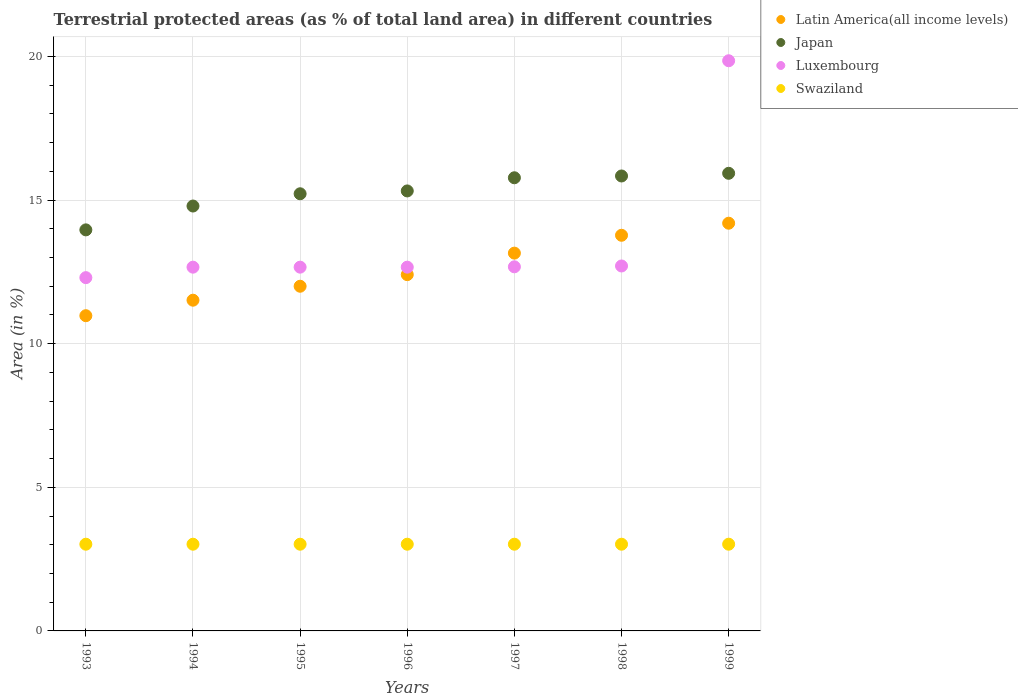How many different coloured dotlines are there?
Offer a very short reply. 4. What is the percentage of terrestrial protected land in Swaziland in 1996?
Your answer should be very brief. 3.02. Across all years, what is the maximum percentage of terrestrial protected land in Japan?
Provide a succinct answer. 15.93. Across all years, what is the minimum percentage of terrestrial protected land in Swaziland?
Make the answer very short. 3.02. In which year was the percentage of terrestrial protected land in Luxembourg maximum?
Offer a terse response. 1999. In which year was the percentage of terrestrial protected land in Japan minimum?
Keep it short and to the point. 1993. What is the total percentage of terrestrial protected land in Swaziland in the graph?
Offer a very short reply. 21.13. What is the difference between the percentage of terrestrial protected land in Latin America(all income levels) in 1998 and that in 1999?
Provide a short and direct response. -0.42. What is the difference between the percentage of terrestrial protected land in Luxembourg in 1998 and the percentage of terrestrial protected land in Swaziland in 1994?
Give a very brief answer. 9.69. What is the average percentage of terrestrial protected land in Swaziland per year?
Your response must be concise. 3.02. In the year 1999, what is the difference between the percentage of terrestrial protected land in Japan and percentage of terrestrial protected land in Latin America(all income levels)?
Your answer should be compact. 1.74. What is the ratio of the percentage of terrestrial protected land in Latin America(all income levels) in 1993 to that in 1999?
Offer a terse response. 0.77. What is the difference between the highest and the second highest percentage of terrestrial protected land in Luxembourg?
Ensure brevity in your answer.  7.14. What is the difference between the highest and the lowest percentage of terrestrial protected land in Japan?
Your answer should be compact. 1.97. Is it the case that in every year, the sum of the percentage of terrestrial protected land in Luxembourg and percentage of terrestrial protected land in Latin America(all income levels)  is greater than the percentage of terrestrial protected land in Swaziland?
Offer a terse response. Yes. Is the percentage of terrestrial protected land in Latin America(all income levels) strictly greater than the percentage of terrestrial protected land in Swaziland over the years?
Your answer should be very brief. Yes. What is the difference between two consecutive major ticks on the Y-axis?
Provide a short and direct response. 5. Are the values on the major ticks of Y-axis written in scientific E-notation?
Make the answer very short. No. Does the graph contain any zero values?
Keep it short and to the point. No. Where does the legend appear in the graph?
Provide a short and direct response. Top right. How many legend labels are there?
Offer a terse response. 4. What is the title of the graph?
Offer a terse response. Terrestrial protected areas (as % of total land area) in different countries. What is the label or title of the Y-axis?
Keep it short and to the point. Area (in %). What is the Area (in %) in Latin America(all income levels) in 1993?
Your response must be concise. 10.97. What is the Area (in %) in Japan in 1993?
Your answer should be compact. 13.96. What is the Area (in %) of Luxembourg in 1993?
Provide a short and direct response. 12.3. What is the Area (in %) in Swaziland in 1993?
Your answer should be very brief. 3.02. What is the Area (in %) of Latin America(all income levels) in 1994?
Keep it short and to the point. 11.51. What is the Area (in %) of Japan in 1994?
Offer a terse response. 14.79. What is the Area (in %) of Luxembourg in 1994?
Make the answer very short. 12.66. What is the Area (in %) of Swaziland in 1994?
Your response must be concise. 3.02. What is the Area (in %) of Latin America(all income levels) in 1995?
Ensure brevity in your answer.  12. What is the Area (in %) in Japan in 1995?
Offer a terse response. 15.22. What is the Area (in %) in Luxembourg in 1995?
Provide a short and direct response. 12.66. What is the Area (in %) in Swaziland in 1995?
Your answer should be compact. 3.02. What is the Area (in %) of Latin America(all income levels) in 1996?
Ensure brevity in your answer.  12.4. What is the Area (in %) in Japan in 1996?
Your response must be concise. 15.32. What is the Area (in %) in Luxembourg in 1996?
Keep it short and to the point. 12.66. What is the Area (in %) of Swaziland in 1996?
Your answer should be very brief. 3.02. What is the Area (in %) in Latin America(all income levels) in 1997?
Provide a succinct answer. 13.15. What is the Area (in %) in Japan in 1997?
Your answer should be very brief. 15.77. What is the Area (in %) in Luxembourg in 1997?
Your response must be concise. 12.67. What is the Area (in %) of Swaziland in 1997?
Your response must be concise. 3.02. What is the Area (in %) in Latin America(all income levels) in 1998?
Provide a succinct answer. 13.77. What is the Area (in %) in Japan in 1998?
Make the answer very short. 15.84. What is the Area (in %) of Luxembourg in 1998?
Keep it short and to the point. 12.7. What is the Area (in %) of Swaziland in 1998?
Keep it short and to the point. 3.02. What is the Area (in %) in Latin America(all income levels) in 1999?
Provide a succinct answer. 14.19. What is the Area (in %) of Japan in 1999?
Keep it short and to the point. 15.93. What is the Area (in %) in Luxembourg in 1999?
Give a very brief answer. 19.85. What is the Area (in %) in Swaziland in 1999?
Provide a short and direct response. 3.02. Across all years, what is the maximum Area (in %) in Latin America(all income levels)?
Provide a succinct answer. 14.19. Across all years, what is the maximum Area (in %) in Japan?
Your answer should be very brief. 15.93. Across all years, what is the maximum Area (in %) of Luxembourg?
Keep it short and to the point. 19.85. Across all years, what is the maximum Area (in %) of Swaziland?
Ensure brevity in your answer.  3.02. Across all years, what is the minimum Area (in %) in Latin America(all income levels)?
Make the answer very short. 10.97. Across all years, what is the minimum Area (in %) in Japan?
Provide a short and direct response. 13.96. Across all years, what is the minimum Area (in %) in Luxembourg?
Your answer should be very brief. 12.3. Across all years, what is the minimum Area (in %) of Swaziland?
Make the answer very short. 3.02. What is the total Area (in %) of Latin America(all income levels) in the graph?
Offer a terse response. 88. What is the total Area (in %) of Japan in the graph?
Provide a succinct answer. 106.83. What is the total Area (in %) in Luxembourg in the graph?
Your answer should be compact. 95.51. What is the total Area (in %) of Swaziland in the graph?
Your answer should be very brief. 21.13. What is the difference between the Area (in %) in Latin America(all income levels) in 1993 and that in 1994?
Your answer should be compact. -0.54. What is the difference between the Area (in %) in Japan in 1993 and that in 1994?
Ensure brevity in your answer.  -0.83. What is the difference between the Area (in %) in Luxembourg in 1993 and that in 1994?
Make the answer very short. -0.36. What is the difference between the Area (in %) in Swaziland in 1993 and that in 1994?
Give a very brief answer. 0. What is the difference between the Area (in %) in Latin America(all income levels) in 1993 and that in 1995?
Provide a succinct answer. -1.03. What is the difference between the Area (in %) of Japan in 1993 and that in 1995?
Your response must be concise. -1.26. What is the difference between the Area (in %) in Luxembourg in 1993 and that in 1995?
Give a very brief answer. -0.36. What is the difference between the Area (in %) of Swaziland in 1993 and that in 1995?
Make the answer very short. 0. What is the difference between the Area (in %) in Latin America(all income levels) in 1993 and that in 1996?
Your answer should be very brief. -1.43. What is the difference between the Area (in %) of Japan in 1993 and that in 1996?
Give a very brief answer. -1.36. What is the difference between the Area (in %) in Luxembourg in 1993 and that in 1996?
Give a very brief answer. -0.36. What is the difference between the Area (in %) in Latin America(all income levels) in 1993 and that in 1997?
Offer a terse response. -2.18. What is the difference between the Area (in %) in Japan in 1993 and that in 1997?
Your response must be concise. -1.81. What is the difference between the Area (in %) in Luxembourg in 1993 and that in 1997?
Make the answer very short. -0.38. What is the difference between the Area (in %) in Swaziland in 1993 and that in 1997?
Your answer should be compact. 0. What is the difference between the Area (in %) of Latin America(all income levels) in 1993 and that in 1998?
Ensure brevity in your answer.  -2.8. What is the difference between the Area (in %) of Japan in 1993 and that in 1998?
Your answer should be very brief. -1.88. What is the difference between the Area (in %) of Luxembourg in 1993 and that in 1998?
Make the answer very short. -0.41. What is the difference between the Area (in %) in Latin America(all income levels) in 1993 and that in 1999?
Provide a short and direct response. -3.22. What is the difference between the Area (in %) in Japan in 1993 and that in 1999?
Provide a short and direct response. -1.97. What is the difference between the Area (in %) in Luxembourg in 1993 and that in 1999?
Your answer should be very brief. -7.55. What is the difference between the Area (in %) of Swaziland in 1993 and that in 1999?
Give a very brief answer. 0. What is the difference between the Area (in %) of Latin America(all income levels) in 1994 and that in 1995?
Offer a terse response. -0.49. What is the difference between the Area (in %) in Japan in 1994 and that in 1995?
Make the answer very short. -0.43. What is the difference between the Area (in %) of Luxembourg in 1994 and that in 1995?
Your answer should be compact. 0. What is the difference between the Area (in %) of Latin America(all income levels) in 1994 and that in 1996?
Give a very brief answer. -0.89. What is the difference between the Area (in %) of Japan in 1994 and that in 1996?
Your answer should be very brief. -0.53. What is the difference between the Area (in %) in Swaziland in 1994 and that in 1996?
Provide a succinct answer. 0. What is the difference between the Area (in %) in Latin America(all income levels) in 1994 and that in 1997?
Provide a short and direct response. -1.64. What is the difference between the Area (in %) of Japan in 1994 and that in 1997?
Give a very brief answer. -0.98. What is the difference between the Area (in %) in Luxembourg in 1994 and that in 1997?
Your answer should be compact. -0.01. What is the difference between the Area (in %) in Swaziland in 1994 and that in 1997?
Your response must be concise. 0. What is the difference between the Area (in %) of Latin America(all income levels) in 1994 and that in 1998?
Offer a very short reply. -2.26. What is the difference between the Area (in %) of Japan in 1994 and that in 1998?
Provide a succinct answer. -1.05. What is the difference between the Area (in %) in Luxembourg in 1994 and that in 1998?
Give a very brief answer. -0.04. What is the difference between the Area (in %) of Latin America(all income levels) in 1994 and that in 1999?
Provide a short and direct response. -2.68. What is the difference between the Area (in %) of Japan in 1994 and that in 1999?
Give a very brief answer. -1.14. What is the difference between the Area (in %) of Luxembourg in 1994 and that in 1999?
Offer a very short reply. -7.19. What is the difference between the Area (in %) in Swaziland in 1994 and that in 1999?
Your answer should be very brief. 0. What is the difference between the Area (in %) in Latin America(all income levels) in 1995 and that in 1996?
Keep it short and to the point. -0.4. What is the difference between the Area (in %) in Japan in 1995 and that in 1996?
Your answer should be very brief. -0.1. What is the difference between the Area (in %) in Latin America(all income levels) in 1995 and that in 1997?
Your answer should be very brief. -1.15. What is the difference between the Area (in %) of Japan in 1995 and that in 1997?
Offer a very short reply. -0.56. What is the difference between the Area (in %) in Luxembourg in 1995 and that in 1997?
Offer a very short reply. -0.01. What is the difference between the Area (in %) in Swaziland in 1995 and that in 1997?
Keep it short and to the point. 0. What is the difference between the Area (in %) in Latin America(all income levels) in 1995 and that in 1998?
Offer a terse response. -1.77. What is the difference between the Area (in %) in Japan in 1995 and that in 1998?
Make the answer very short. -0.62. What is the difference between the Area (in %) of Luxembourg in 1995 and that in 1998?
Your answer should be very brief. -0.04. What is the difference between the Area (in %) of Latin America(all income levels) in 1995 and that in 1999?
Keep it short and to the point. -2.19. What is the difference between the Area (in %) of Japan in 1995 and that in 1999?
Your answer should be very brief. -0.71. What is the difference between the Area (in %) in Luxembourg in 1995 and that in 1999?
Provide a short and direct response. -7.19. What is the difference between the Area (in %) of Latin America(all income levels) in 1996 and that in 1997?
Your response must be concise. -0.75. What is the difference between the Area (in %) in Japan in 1996 and that in 1997?
Your answer should be compact. -0.46. What is the difference between the Area (in %) in Luxembourg in 1996 and that in 1997?
Ensure brevity in your answer.  -0.01. What is the difference between the Area (in %) of Latin America(all income levels) in 1996 and that in 1998?
Provide a succinct answer. -1.37. What is the difference between the Area (in %) of Japan in 1996 and that in 1998?
Keep it short and to the point. -0.52. What is the difference between the Area (in %) in Luxembourg in 1996 and that in 1998?
Provide a succinct answer. -0.04. What is the difference between the Area (in %) in Swaziland in 1996 and that in 1998?
Your response must be concise. 0. What is the difference between the Area (in %) of Latin America(all income levels) in 1996 and that in 1999?
Your answer should be compact. -1.79. What is the difference between the Area (in %) in Japan in 1996 and that in 1999?
Provide a short and direct response. -0.61. What is the difference between the Area (in %) of Luxembourg in 1996 and that in 1999?
Give a very brief answer. -7.19. What is the difference between the Area (in %) of Latin America(all income levels) in 1997 and that in 1998?
Ensure brevity in your answer.  -0.62. What is the difference between the Area (in %) of Japan in 1997 and that in 1998?
Offer a terse response. -0.06. What is the difference between the Area (in %) in Luxembourg in 1997 and that in 1998?
Your answer should be very brief. -0.03. What is the difference between the Area (in %) of Swaziland in 1997 and that in 1998?
Provide a succinct answer. 0. What is the difference between the Area (in %) in Latin America(all income levels) in 1997 and that in 1999?
Offer a very short reply. -1.04. What is the difference between the Area (in %) of Japan in 1997 and that in 1999?
Your response must be concise. -0.16. What is the difference between the Area (in %) in Luxembourg in 1997 and that in 1999?
Make the answer very short. -7.17. What is the difference between the Area (in %) in Latin America(all income levels) in 1998 and that in 1999?
Your answer should be very brief. -0.42. What is the difference between the Area (in %) of Japan in 1998 and that in 1999?
Keep it short and to the point. -0.09. What is the difference between the Area (in %) in Luxembourg in 1998 and that in 1999?
Offer a terse response. -7.14. What is the difference between the Area (in %) in Latin America(all income levels) in 1993 and the Area (in %) in Japan in 1994?
Your answer should be compact. -3.82. What is the difference between the Area (in %) of Latin America(all income levels) in 1993 and the Area (in %) of Luxembourg in 1994?
Provide a short and direct response. -1.69. What is the difference between the Area (in %) of Latin America(all income levels) in 1993 and the Area (in %) of Swaziland in 1994?
Keep it short and to the point. 7.95. What is the difference between the Area (in %) of Japan in 1993 and the Area (in %) of Luxembourg in 1994?
Your answer should be compact. 1.3. What is the difference between the Area (in %) of Japan in 1993 and the Area (in %) of Swaziland in 1994?
Keep it short and to the point. 10.94. What is the difference between the Area (in %) of Luxembourg in 1993 and the Area (in %) of Swaziland in 1994?
Your response must be concise. 9.28. What is the difference between the Area (in %) of Latin America(all income levels) in 1993 and the Area (in %) of Japan in 1995?
Your response must be concise. -4.24. What is the difference between the Area (in %) of Latin America(all income levels) in 1993 and the Area (in %) of Luxembourg in 1995?
Provide a succinct answer. -1.69. What is the difference between the Area (in %) of Latin America(all income levels) in 1993 and the Area (in %) of Swaziland in 1995?
Your answer should be very brief. 7.95. What is the difference between the Area (in %) of Japan in 1993 and the Area (in %) of Luxembourg in 1995?
Offer a very short reply. 1.3. What is the difference between the Area (in %) of Japan in 1993 and the Area (in %) of Swaziland in 1995?
Provide a succinct answer. 10.94. What is the difference between the Area (in %) of Luxembourg in 1993 and the Area (in %) of Swaziland in 1995?
Your response must be concise. 9.28. What is the difference between the Area (in %) in Latin America(all income levels) in 1993 and the Area (in %) in Japan in 1996?
Give a very brief answer. -4.34. What is the difference between the Area (in %) of Latin America(all income levels) in 1993 and the Area (in %) of Luxembourg in 1996?
Your response must be concise. -1.69. What is the difference between the Area (in %) in Latin America(all income levels) in 1993 and the Area (in %) in Swaziland in 1996?
Offer a very short reply. 7.95. What is the difference between the Area (in %) of Japan in 1993 and the Area (in %) of Luxembourg in 1996?
Make the answer very short. 1.3. What is the difference between the Area (in %) in Japan in 1993 and the Area (in %) in Swaziland in 1996?
Offer a terse response. 10.94. What is the difference between the Area (in %) in Luxembourg in 1993 and the Area (in %) in Swaziland in 1996?
Make the answer very short. 9.28. What is the difference between the Area (in %) in Latin America(all income levels) in 1993 and the Area (in %) in Japan in 1997?
Offer a terse response. -4.8. What is the difference between the Area (in %) of Latin America(all income levels) in 1993 and the Area (in %) of Luxembourg in 1997?
Your response must be concise. -1.7. What is the difference between the Area (in %) in Latin America(all income levels) in 1993 and the Area (in %) in Swaziland in 1997?
Keep it short and to the point. 7.95. What is the difference between the Area (in %) in Japan in 1993 and the Area (in %) in Luxembourg in 1997?
Offer a terse response. 1.29. What is the difference between the Area (in %) of Japan in 1993 and the Area (in %) of Swaziland in 1997?
Keep it short and to the point. 10.94. What is the difference between the Area (in %) in Luxembourg in 1993 and the Area (in %) in Swaziland in 1997?
Provide a succinct answer. 9.28. What is the difference between the Area (in %) of Latin America(all income levels) in 1993 and the Area (in %) of Japan in 1998?
Keep it short and to the point. -4.86. What is the difference between the Area (in %) in Latin America(all income levels) in 1993 and the Area (in %) in Luxembourg in 1998?
Your answer should be very brief. -1.73. What is the difference between the Area (in %) in Latin America(all income levels) in 1993 and the Area (in %) in Swaziland in 1998?
Ensure brevity in your answer.  7.95. What is the difference between the Area (in %) of Japan in 1993 and the Area (in %) of Luxembourg in 1998?
Keep it short and to the point. 1.26. What is the difference between the Area (in %) of Japan in 1993 and the Area (in %) of Swaziland in 1998?
Your answer should be very brief. 10.94. What is the difference between the Area (in %) of Luxembourg in 1993 and the Area (in %) of Swaziland in 1998?
Provide a succinct answer. 9.28. What is the difference between the Area (in %) of Latin America(all income levels) in 1993 and the Area (in %) of Japan in 1999?
Your answer should be compact. -4.96. What is the difference between the Area (in %) of Latin America(all income levels) in 1993 and the Area (in %) of Luxembourg in 1999?
Your answer should be compact. -8.87. What is the difference between the Area (in %) in Latin America(all income levels) in 1993 and the Area (in %) in Swaziland in 1999?
Offer a terse response. 7.95. What is the difference between the Area (in %) of Japan in 1993 and the Area (in %) of Luxembourg in 1999?
Provide a short and direct response. -5.89. What is the difference between the Area (in %) of Japan in 1993 and the Area (in %) of Swaziland in 1999?
Provide a succinct answer. 10.94. What is the difference between the Area (in %) of Luxembourg in 1993 and the Area (in %) of Swaziland in 1999?
Provide a short and direct response. 9.28. What is the difference between the Area (in %) of Latin America(all income levels) in 1994 and the Area (in %) of Japan in 1995?
Give a very brief answer. -3.7. What is the difference between the Area (in %) in Latin America(all income levels) in 1994 and the Area (in %) in Luxembourg in 1995?
Offer a terse response. -1.15. What is the difference between the Area (in %) in Latin America(all income levels) in 1994 and the Area (in %) in Swaziland in 1995?
Your response must be concise. 8.49. What is the difference between the Area (in %) in Japan in 1994 and the Area (in %) in Luxembourg in 1995?
Offer a very short reply. 2.13. What is the difference between the Area (in %) of Japan in 1994 and the Area (in %) of Swaziland in 1995?
Keep it short and to the point. 11.77. What is the difference between the Area (in %) in Luxembourg in 1994 and the Area (in %) in Swaziland in 1995?
Make the answer very short. 9.64. What is the difference between the Area (in %) in Latin America(all income levels) in 1994 and the Area (in %) in Japan in 1996?
Ensure brevity in your answer.  -3.8. What is the difference between the Area (in %) of Latin America(all income levels) in 1994 and the Area (in %) of Luxembourg in 1996?
Ensure brevity in your answer.  -1.15. What is the difference between the Area (in %) in Latin America(all income levels) in 1994 and the Area (in %) in Swaziland in 1996?
Offer a very short reply. 8.49. What is the difference between the Area (in %) in Japan in 1994 and the Area (in %) in Luxembourg in 1996?
Ensure brevity in your answer.  2.13. What is the difference between the Area (in %) in Japan in 1994 and the Area (in %) in Swaziland in 1996?
Make the answer very short. 11.77. What is the difference between the Area (in %) in Luxembourg in 1994 and the Area (in %) in Swaziland in 1996?
Provide a short and direct response. 9.64. What is the difference between the Area (in %) in Latin America(all income levels) in 1994 and the Area (in %) in Japan in 1997?
Keep it short and to the point. -4.26. What is the difference between the Area (in %) in Latin America(all income levels) in 1994 and the Area (in %) in Luxembourg in 1997?
Your answer should be compact. -1.16. What is the difference between the Area (in %) in Latin America(all income levels) in 1994 and the Area (in %) in Swaziland in 1997?
Your response must be concise. 8.49. What is the difference between the Area (in %) of Japan in 1994 and the Area (in %) of Luxembourg in 1997?
Give a very brief answer. 2.12. What is the difference between the Area (in %) of Japan in 1994 and the Area (in %) of Swaziland in 1997?
Provide a short and direct response. 11.77. What is the difference between the Area (in %) in Luxembourg in 1994 and the Area (in %) in Swaziland in 1997?
Ensure brevity in your answer.  9.64. What is the difference between the Area (in %) in Latin America(all income levels) in 1994 and the Area (in %) in Japan in 1998?
Offer a very short reply. -4.32. What is the difference between the Area (in %) in Latin America(all income levels) in 1994 and the Area (in %) in Luxembourg in 1998?
Offer a very short reply. -1.19. What is the difference between the Area (in %) of Latin America(all income levels) in 1994 and the Area (in %) of Swaziland in 1998?
Keep it short and to the point. 8.49. What is the difference between the Area (in %) in Japan in 1994 and the Area (in %) in Luxembourg in 1998?
Offer a terse response. 2.09. What is the difference between the Area (in %) of Japan in 1994 and the Area (in %) of Swaziland in 1998?
Your answer should be compact. 11.77. What is the difference between the Area (in %) in Luxembourg in 1994 and the Area (in %) in Swaziland in 1998?
Give a very brief answer. 9.64. What is the difference between the Area (in %) of Latin America(all income levels) in 1994 and the Area (in %) of Japan in 1999?
Keep it short and to the point. -4.42. What is the difference between the Area (in %) in Latin America(all income levels) in 1994 and the Area (in %) in Luxembourg in 1999?
Provide a succinct answer. -8.34. What is the difference between the Area (in %) in Latin America(all income levels) in 1994 and the Area (in %) in Swaziland in 1999?
Offer a terse response. 8.49. What is the difference between the Area (in %) in Japan in 1994 and the Area (in %) in Luxembourg in 1999?
Provide a short and direct response. -5.06. What is the difference between the Area (in %) in Japan in 1994 and the Area (in %) in Swaziland in 1999?
Provide a short and direct response. 11.77. What is the difference between the Area (in %) in Luxembourg in 1994 and the Area (in %) in Swaziland in 1999?
Keep it short and to the point. 9.64. What is the difference between the Area (in %) in Latin America(all income levels) in 1995 and the Area (in %) in Japan in 1996?
Make the answer very short. -3.32. What is the difference between the Area (in %) of Latin America(all income levels) in 1995 and the Area (in %) of Luxembourg in 1996?
Ensure brevity in your answer.  -0.66. What is the difference between the Area (in %) in Latin America(all income levels) in 1995 and the Area (in %) in Swaziland in 1996?
Your answer should be compact. 8.98. What is the difference between the Area (in %) of Japan in 1995 and the Area (in %) of Luxembourg in 1996?
Your answer should be very brief. 2.55. What is the difference between the Area (in %) of Japan in 1995 and the Area (in %) of Swaziland in 1996?
Ensure brevity in your answer.  12.2. What is the difference between the Area (in %) of Luxembourg in 1995 and the Area (in %) of Swaziland in 1996?
Provide a short and direct response. 9.64. What is the difference between the Area (in %) in Latin America(all income levels) in 1995 and the Area (in %) in Japan in 1997?
Make the answer very short. -3.78. What is the difference between the Area (in %) of Latin America(all income levels) in 1995 and the Area (in %) of Luxembourg in 1997?
Provide a succinct answer. -0.68. What is the difference between the Area (in %) of Latin America(all income levels) in 1995 and the Area (in %) of Swaziland in 1997?
Your answer should be very brief. 8.98. What is the difference between the Area (in %) of Japan in 1995 and the Area (in %) of Luxembourg in 1997?
Your response must be concise. 2.54. What is the difference between the Area (in %) of Japan in 1995 and the Area (in %) of Swaziland in 1997?
Keep it short and to the point. 12.2. What is the difference between the Area (in %) in Luxembourg in 1995 and the Area (in %) in Swaziland in 1997?
Your response must be concise. 9.64. What is the difference between the Area (in %) in Latin America(all income levels) in 1995 and the Area (in %) in Japan in 1998?
Ensure brevity in your answer.  -3.84. What is the difference between the Area (in %) of Latin America(all income levels) in 1995 and the Area (in %) of Luxembourg in 1998?
Your response must be concise. -0.71. What is the difference between the Area (in %) of Latin America(all income levels) in 1995 and the Area (in %) of Swaziland in 1998?
Your answer should be very brief. 8.98. What is the difference between the Area (in %) in Japan in 1995 and the Area (in %) in Luxembourg in 1998?
Provide a succinct answer. 2.51. What is the difference between the Area (in %) in Japan in 1995 and the Area (in %) in Swaziland in 1998?
Keep it short and to the point. 12.2. What is the difference between the Area (in %) of Luxembourg in 1995 and the Area (in %) of Swaziland in 1998?
Ensure brevity in your answer.  9.64. What is the difference between the Area (in %) in Latin America(all income levels) in 1995 and the Area (in %) in Japan in 1999?
Make the answer very short. -3.93. What is the difference between the Area (in %) of Latin America(all income levels) in 1995 and the Area (in %) of Luxembourg in 1999?
Provide a short and direct response. -7.85. What is the difference between the Area (in %) in Latin America(all income levels) in 1995 and the Area (in %) in Swaziland in 1999?
Your response must be concise. 8.98. What is the difference between the Area (in %) in Japan in 1995 and the Area (in %) in Luxembourg in 1999?
Give a very brief answer. -4.63. What is the difference between the Area (in %) of Japan in 1995 and the Area (in %) of Swaziland in 1999?
Offer a terse response. 12.2. What is the difference between the Area (in %) of Luxembourg in 1995 and the Area (in %) of Swaziland in 1999?
Make the answer very short. 9.64. What is the difference between the Area (in %) of Latin America(all income levels) in 1996 and the Area (in %) of Japan in 1997?
Provide a succinct answer. -3.37. What is the difference between the Area (in %) in Latin America(all income levels) in 1996 and the Area (in %) in Luxembourg in 1997?
Provide a short and direct response. -0.27. What is the difference between the Area (in %) of Latin America(all income levels) in 1996 and the Area (in %) of Swaziland in 1997?
Give a very brief answer. 9.38. What is the difference between the Area (in %) of Japan in 1996 and the Area (in %) of Luxembourg in 1997?
Your answer should be very brief. 2.64. What is the difference between the Area (in %) in Japan in 1996 and the Area (in %) in Swaziland in 1997?
Offer a very short reply. 12.3. What is the difference between the Area (in %) of Luxembourg in 1996 and the Area (in %) of Swaziland in 1997?
Your answer should be compact. 9.64. What is the difference between the Area (in %) in Latin America(all income levels) in 1996 and the Area (in %) in Japan in 1998?
Your answer should be compact. -3.43. What is the difference between the Area (in %) in Latin America(all income levels) in 1996 and the Area (in %) in Luxembourg in 1998?
Your answer should be very brief. -0.3. What is the difference between the Area (in %) of Latin America(all income levels) in 1996 and the Area (in %) of Swaziland in 1998?
Make the answer very short. 9.38. What is the difference between the Area (in %) in Japan in 1996 and the Area (in %) in Luxembourg in 1998?
Your response must be concise. 2.61. What is the difference between the Area (in %) in Japan in 1996 and the Area (in %) in Swaziland in 1998?
Make the answer very short. 12.3. What is the difference between the Area (in %) of Luxembourg in 1996 and the Area (in %) of Swaziland in 1998?
Your response must be concise. 9.64. What is the difference between the Area (in %) of Latin America(all income levels) in 1996 and the Area (in %) of Japan in 1999?
Your response must be concise. -3.53. What is the difference between the Area (in %) of Latin America(all income levels) in 1996 and the Area (in %) of Luxembourg in 1999?
Offer a very short reply. -7.45. What is the difference between the Area (in %) in Latin America(all income levels) in 1996 and the Area (in %) in Swaziland in 1999?
Make the answer very short. 9.38. What is the difference between the Area (in %) of Japan in 1996 and the Area (in %) of Luxembourg in 1999?
Your answer should be compact. -4.53. What is the difference between the Area (in %) of Japan in 1996 and the Area (in %) of Swaziland in 1999?
Make the answer very short. 12.3. What is the difference between the Area (in %) in Luxembourg in 1996 and the Area (in %) in Swaziland in 1999?
Make the answer very short. 9.64. What is the difference between the Area (in %) of Latin America(all income levels) in 1997 and the Area (in %) of Japan in 1998?
Give a very brief answer. -2.69. What is the difference between the Area (in %) of Latin America(all income levels) in 1997 and the Area (in %) of Luxembourg in 1998?
Make the answer very short. 0.45. What is the difference between the Area (in %) of Latin America(all income levels) in 1997 and the Area (in %) of Swaziland in 1998?
Provide a succinct answer. 10.13. What is the difference between the Area (in %) of Japan in 1997 and the Area (in %) of Luxembourg in 1998?
Your answer should be very brief. 3.07. What is the difference between the Area (in %) in Japan in 1997 and the Area (in %) in Swaziland in 1998?
Provide a succinct answer. 12.76. What is the difference between the Area (in %) in Luxembourg in 1997 and the Area (in %) in Swaziland in 1998?
Your answer should be compact. 9.66. What is the difference between the Area (in %) in Latin America(all income levels) in 1997 and the Area (in %) in Japan in 1999?
Keep it short and to the point. -2.78. What is the difference between the Area (in %) of Latin America(all income levels) in 1997 and the Area (in %) of Luxembourg in 1999?
Your answer should be compact. -6.7. What is the difference between the Area (in %) in Latin America(all income levels) in 1997 and the Area (in %) in Swaziland in 1999?
Give a very brief answer. 10.13. What is the difference between the Area (in %) of Japan in 1997 and the Area (in %) of Luxembourg in 1999?
Make the answer very short. -4.07. What is the difference between the Area (in %) of Japan in 1997 and the Area (in %) of Swaziland in 1999?
Your response must be concise. 12.76. What is the difference between the Area (in %) in Luxembourg in 1997 and the Area (in %) in Swaziland in 1999?
Your response must be concise. 9.66. What is the difference between the Area (in %) of Latin America(all income levels) in 1998 and the Area (in %) of Japan in 1999?
Ensure brevity in your answer.  -2.16. What is the difference between the Area (in %) of Latin America(all income levels) in 1998 and the Area (in %) of Luxembourg in 1999?
Ensure brevity in your answer.  -6.08. What is the difference between the Area (in %) of Latin America(all income levels) in 1998 and the Area (in %) of Swaziland in 1999?
Ensure brevity in your answer.  10.75. What is the difference between the Area (in %) in Japan in 1998 and the Area (in %) in Luxembourg in 1999?
Ensure brevity in your answer.  -4.01. What is the difference between the Area (in %) in Japan in 1998 and the Area (in %) in Swaziland in 1999?
Provide a short and direct response. 12.82. What is the difference between the Area (in %) in Luxembourg in 1998 and the Area (in %) in Swaziland in 1999?
Offer a very short reply. 9.69. What is the average Area (in %) in Latin America(all income levels) per year?
Ensure brevity in your answer.  12.57. What is the average Area (in %) of Japan per year?
Provide a succinct answer. 15.26. What is the average Area (in %) in Luxembourg per year?
Your answer should be compact. 13.64. What is the average Area (in %) of Swaziland per year?
Your answer should be compact. 3.02. In the year 1993, what is the difference between the Area (in %) of Latin America(all income levels) and Area (in %) of Japan?
Ensure brevity in your answer.  -2.99. In the year 1993, what is the difference between the Area (in %) in Latin America(all income levels) and Area (in %) in Luxembourg?
Offer a very short reply. -1.32. In the year 1993, what is the difference between the Area (in %) of Latin America(all income levels) and Area (in %) of Swaziland?
Provide a succinct answer. 7.95. In the year 1993, what is the difference between the Area (in %) of Japan and Area (in %) of Luxembourg?
Your response must be concise. 1.66. In the year 1993, what is the difference between the Area (in %) in Japan and Area (in %) in Swaziland?
Offer a terse response. 10.94. In the year 1993, what is the difference between the Area (in %) of Luxembourg and Area (in %) of Swaziland?
Provide a short and direct response. 9.28. In the year 1994, what is the difference between the Area (in %) in Latin America(all income levels) and Area (in %) in Japan?
Your response must be concise. -3.28. In the year 1994, what is the difference between the Area (in %) of Latin America(all income levels) and Area (in %) of Luxembourg?
Keep it short and to the point. -1.15. In the year 1994, what is the difference between the Area (in %) in Latin America(all income levels) and Area (in %) in Swaziland?
Make the answer very short. 8.49. In the year 1994, what is the difference between the Area (in %) of Japan and Area (in %) of Luxembourg?
Provide a succinct answer. 2.13. In the year 1994, what is the difference between the Area (in %) in Japan and Area (in %) in Swaziland?
Give a very brief answer. 11.77. In the year 1994, what is the difference between the Area (in %) in Luxembourg and Area (in %) in Swaziland?
Make the answer very short. 9.64. In the year 1995, what is the difference between the Area (in %) in Latin America(all income levels) and Area (in %) in Japan?
Provide a short and direct response. -3.22. In the year 1995, what is the difference between the Area (in %) in Latin America(all income levels) and Area (in %) in Luxembourg?
Make the answer very short. -0.66. In the year 1995, what is the difference between the Area (in %) in Latin America(all income levels) and Area (in %) in Swaziland?
Give a very brief answer. 8.98. In the year 1995, what is the difference between the Area (in %) of Japan and Area (in %) of Luxembourg?
Offer a very short reply. 2.55. In the year 1995, what is the difference between the Area (in %) of Japan and Area (in %) of Swaziland?
Your answer should be compact. 12.2. In the year 1995, what is the difference between the Area (in %) of Luxembourg and Area (in %) of Swaziland?
Offer a terse response. 9.64. In the year 1996, what is the difference between the Area (in %) of Latin America(all income levels) and Area (in %) of Japan?
Make the answer very short. -2.91. In the year 1996, what is the difference between the Area (in %) of Latin America(all income levels) and Area (in %) of Luxembourg?
Provide a succinct answer. -0.26. In the year 1996, what is the difference between the Area (in %) in Latin America(all income levels) and Area (in %) in Swaziland?
Your answer should be very brief. 9.38. In the year 1996, what is the difference between the Area (in %) in Japan and Area (in %) in Luxembourg?
Your answer should be compact. 2.65. In the year 1996, what is the difference between the Area (in %) in Japan and Area (in %) in Swaziland?
Ensure brevity in your answer.  12.3. In the year 1996, what is the difference between the Area (in %) of Luxembourg and Area (in %) of Swaziland?
Provide a short and direct response. 9.64. In the year 1997, what is the difference between the Area (in %) in Latin America(all income levels) and Area (in %) in Japan?
Your answer should be very brief. -2.62. In the year 1997, what is the difference between the Area (in %) in Latin America(all income levels) and Area (in %) in Luxembourg?
Your response must be concise. 0.48. In the year 1997, what is the difference between the Area (in %) in Latin America(all income levels) and Area (in %) in Swaziland?
Offer a terse response. 10.13. In the year 1997, what is the difference between the Area (in %) of Japan and Area (in %) of Luxembourg?
Give a very brief answer. 3.1. In the year 1997, what is the difference between the Area (in %) of Japan and Area (in %) of Swaziland?
Keep it short and to the point. 12.76. In the year 1997, what is the difference between the Area (in %) of Luxembourg and Area (in %) of Swaziland?
Offer a very short reply. 9.66. In the year 1998, what is the difference between the Area (in %) in Latin America(all income levels) and Area (in %) in Japan?
Give a very brief answer. -2.06. In the year 1998, what is the difference between the Area (in %) in Latin America(all income levels) and Area (in %) in Luxembourg?
Give a very brief answer. 1.07. In the year 1998, what is the difference between the Area (in %) of Latin America(all income levels) and Area (in %) of Swaziland?
Give a very brief answer. 10.75. In the year 1998, what is the difference between the Area (in %) in Japan and Area (in %) in Luxembourg?
Offer a very short reply. 3.13. In the year 1998, what is the difference between the Area (in %) of Japan and Area (in %) of Swaziland?
Your answer should be compact. 12.82. In the year 1998, what is the difference between the Area (in %) in Luxembourg and Area (in %) in Swaziland?
Your response must be concise. 9.69. In the year 1999, what is the difference between the Area (in %) in Latin America(all income levels) and Area (in %) in Japan?
Provide a succinct answer. -1.74. In the year 1999, what is the difference between the Area (in %) of Latin America(all income levels) and Area (in %) of Luxembourg?
Your answer should be very brief. -5.66. In the year 1999, what is the difference between the Area (in %) of Latin America(all income levels) and Area (in %) of Swaziland?
Provide a short and direct response. 11.17. In the year 1999, what is the difference between the Area (in %) in Japan and Area (in %) in Luxembourg?
Your response must be concise. -3.92. In the year 1999, what is the difference between the Area (in %) of Japan and Area (in %) of Swaziland?
Offer a very short reply. 12.91. In the year 1999, what is the difference between the Area (in %) in Luxembourg and Area (in %) in Swaziland?
Keep it short and to the point. 16.83. What is the ratio of the Area (in %) in Latin America(all income levels) in 1993 to that in 1994?
Your response must be concise. 0.95. What is the ratio of the Area (in %) of Japan in 1993 to that in 1994?
Give a very brief answer. 0.94. What is the ratio of the Area (in %) of Luxembourg in 1993 to that in 1994?
Provide a succinct answer. 0.97. What is the ratio of the Area (in %) in Latin America(all income levels) in 1993 to that in 1995?
Provide a short and direct response. 0.91. What is the ratio of the Area (in %) of Japan in 1993 to that in 1995?
Ensure brevity in your answer.  0.92. What is the ratio of the Area (in %) of Luxembourg in 1993 to that in 1995?
Provide a succinct answer. 0.97. What is the ratio of the Area (in %) of Latin America(all income levels) in 1993 to that in 1996?
Offer a very short reply. 0.88. What is the ratio of the Area (in %) in Japan in 1993 to that in 1996?
Make the answer very short. 0.91. What is the ratio of the Area (in %) in Luxembourg in 1993 to that in 1996?
Give a very brief answer. 0.97. What is the ratio of the Area (in %) in Swaziland in 1993 to that in 1996?
Your answer should be very brief. 1. What is the ratio of the Area (in %) in Latin America(all income levels) in 1993 to that in 1997?
Provide a short and direct response. 0.83. What is the ratio of the Area (in %) in Japan in 1993 to that in 1997?
Provide a short and direct response. 0.89. What is the ratio of the Area (in %) of Luxembourg in 1993 to that in 1997?
Keep it short and to the point. 0.97. What is the ratio of the Area (in %) of Swaziland in 1993 to that in 1997?
Offer a very short reply. 1. What is the ratio of the Area (in %) in Latin America(all income levels) in 1993 to that in 1998?
Your answer should be very brief. 0.8. What is the ratio of the Area (in %) of Japan in 1993 to that in 1998?
Ensure brevity in your answer.  0.88. What is the ratio of the Area (in %) of Luxembourg in 1993 to that in 1998?
Offer a very short reply. 0.97. What is the ratio of the Area (in %) in Swaziland in 1993 to that in 1998?
Your response must be concise. 1. What is the ratio of the Area (in %) of Latin America(all income levels) in 1993 to that in 1999?
Offer a very short reply. 0.77. What is the ratio of the Area (in %) in Japan in 1993 to that in 1999?
Give a very brief answer. 0.88. What is the ratio of the Area (in %) in Luxembourg in 1993 to that in 1999?
Offer a very short reply. 0.62. What is the ratio of the Area (in %) of Latin America(all income levels) in 1994 to that in 1995?
Ensure brevity in your answer.  0.96. What is the ratio of the Area (in %) of Japan in 1994 to that in 1995?
Provide a succinct answer. 0.97. What is the ratio of the Area (in %) in Luxembourg in 1994 to that in 1995?
Ensure brevity in your answer.  1. What is the ratio of the Area (in %) of Swaziland in 1994 to that in 1995?
Make the answer very short. 1. What is the ratio of the Area (in %) in Latin America(all income levels) in 1994 to that in 1996?
Provide a succinct answer. 0.93. What is the ratio of the Area (in %) in Japan in 1994 to that in 1996?
Keep it short and to the point. 0.97. What is the ratio of the Area (in %) of Luxembourg in 1994 to that in 1996?
Keep it short and to the point. 1. What is the ratio of the Area (in %) of Swaziland in 1994 to that in 1996?
Make the answer very short. 1. What is the ratio of the Area (in %) in Latin America(all income levels) in 1994 to that in 1997?
Ensure brevity in your answer.  0.88. What is the ratio of the Area (in %) of Japan in 1994 to that in 1997?
Provide a succinct answer. 0.94. What is the ratio of the Area (in %) in Latin America(all income levels) in 1994 to that in 1998?
Your response must be concise. 0.84. What is the ratio of the Area (in %) of Japan in 1994 to that in 1998?
Provide a short and direct response. 0.93. What is the ratio of the Area (in %) of Latin America(all income levels) in 1994 to that in 1999?
Your response must be concise. 0.81. What is the ratio of the Area (in %) of Japan in 1994 to that in 1999?
Provide a succinct answer. 0.93. What is the ratio of the Area (in %) of Luxembourg in 1994 to that in 1999?
Ensure brevity in your answer.  0.64. What is the ratio of the Area (in %) in Latin America(all income levels) in 1995 to that in 1996?
Offer a terse response. 0.97. What is the ratio of the Area (in %) in Luxembourg in 1995 to that in 1996?
Offer a terse response. 1. What is the ratio of the Area (in %) of Swaziland in 1995 to that in 1996?
Give a very brief answer. 1. What is the ratio of the Area (in %) of Latin America(all income levels) in 1995 to that in 1997?
Your answer should be compact. 0.91. What is the ratio of the Area (in %) in Japan in 1995 to that in 1997?
Offer a very short reply. 0.96. What is the ratio of the Area (in %) of Luxembourg in 1995 to that in 1997?
Ensure brevity in your answer.  1. What is the ratio of the Area (in %) in Latin America(all income levels) in 1995 to that in 1998?
Your answer should be compact. 0.87. What is the ratio of the Area (in %) of Japan in 1995 to that in 1998?
Your response must be concise. 0.96. What is the ratio of the Area (in %) in Luxembourg in 1995 to that in 1998?
Your answer should be compact. 1. What is the ratio of the Area (in %) of Latin America(all income levels) in 1995 to that in 1999?
Your answer should be compact. 0.85. What is the ratio of the Area (in %) in Japan in 1995 to that in 1999?
Your answer should be compact. 0.96. What is the ratio of the Area (in %) in Luxembourg in 1995 to that in 1999?
Ensure brevity in your answer.  0.64. What is the ratio of the Area (in %) in Latin America(all income levels) in 1996 to that in 1997?
Keep it short and to the point. 0.94. What is the ratio of the Area (in %) of Japan in 1996 to that in 1997?
Your answer should be very brief. 0.97. What is the ratio of the Area (in %) in Swaziland in 1996 to that in 1997?
Provide a succinct answer. 1. What is the ratio of the Area (in %) of Latin America(all income levels) in 1996 to that in 1998?
Offer a very short reply. 0.9. What is the ratio of the Area (in %) in Japan in 1996 to that in 1998?
Keep it short and to the point. 0.97. What is the ratio of the Area (in %) of Latin America(all income levels) in 1996 to that in 1999?
Keep it short and to the point. 0.87. What is the ratio of the Area (in %) of Japan in 1996 to that in 1999?
Provide a short and direct response. 0.96. What is the ratio of the Area (in %) in Luxembourg in 1996 to that in 1999?
Your response must be concise. 0.64. What is the ratio of the Area (in %) in Latin America(all income levels) in 1997 to that in 1998?
Offer a very short reply. 0.95. What is the ratio of the Area (in %) of Japan in 1997 to that in 1998?
Offer a very short reply. 1. What is the ratio of the Area (in %) of Swaziland in 1997 to that in 1998?
Provide a succinct answer. 1. What is the ratio of the Area (in %) of Latin America(all income levels) in 1997 to that in 1999?
Offer a terse response. 0.93. What is the ratio of the Area (in %) in Japan in 1997 to that in 1999?
Make the answer very short. 0.99. What is the ratio of the Area (in %) of Luxembourg in 1997 to that in 1999?
Provide a succinct answer. 0.64. What is the ratio of the Area (in %) of Swaziland in 1997 to that in 1999?
Make the answer very short. 1. What is the ratio of the Area (in %) in Latin America(all income levels) in 1998 to that in 1999?
Ensure brevity in your answer.  0.97. What is the ratio of the Area (in %) in Japan in 1998 to that in 1999?
Offer a very short reply. 0.99. What is the ratio of the Area (in %) of Luxembourg in 1998 to that in 1999?
Give a very brief answer. 0.64. What is the ratio of the Area (in %) of Swaziland in 1998 to that in 1999?
Make the answer very short. 1. What is the difference between the highest and the second highest Area (in %) in Latin America(all income levels)?
Provide a short and direct response. 0.42. What is the difference between the highest and the second highest Area (in %) of Japan?
Give a very brief answer. 0.09. What is the difference between the highest and the second highest Area (in %) in Luxembourg?
Your response must be concise. 7.14. What is the difference between the highest and the lowest Area (in %) of Latin America(all income levels)?
Provide a succinct answer. 3.22. What is the difference between the highest and the lowest Area (in %) of Japan?
Offer a very short reply. 1.97. What is the difference between the highest and the lowest Area (in %) in Luxembourg?
Your answer should be very brief. 7.55. What is the difference between the highest and the lowest Area (in %) of Swaziland?
Offer a terse response. 0. 